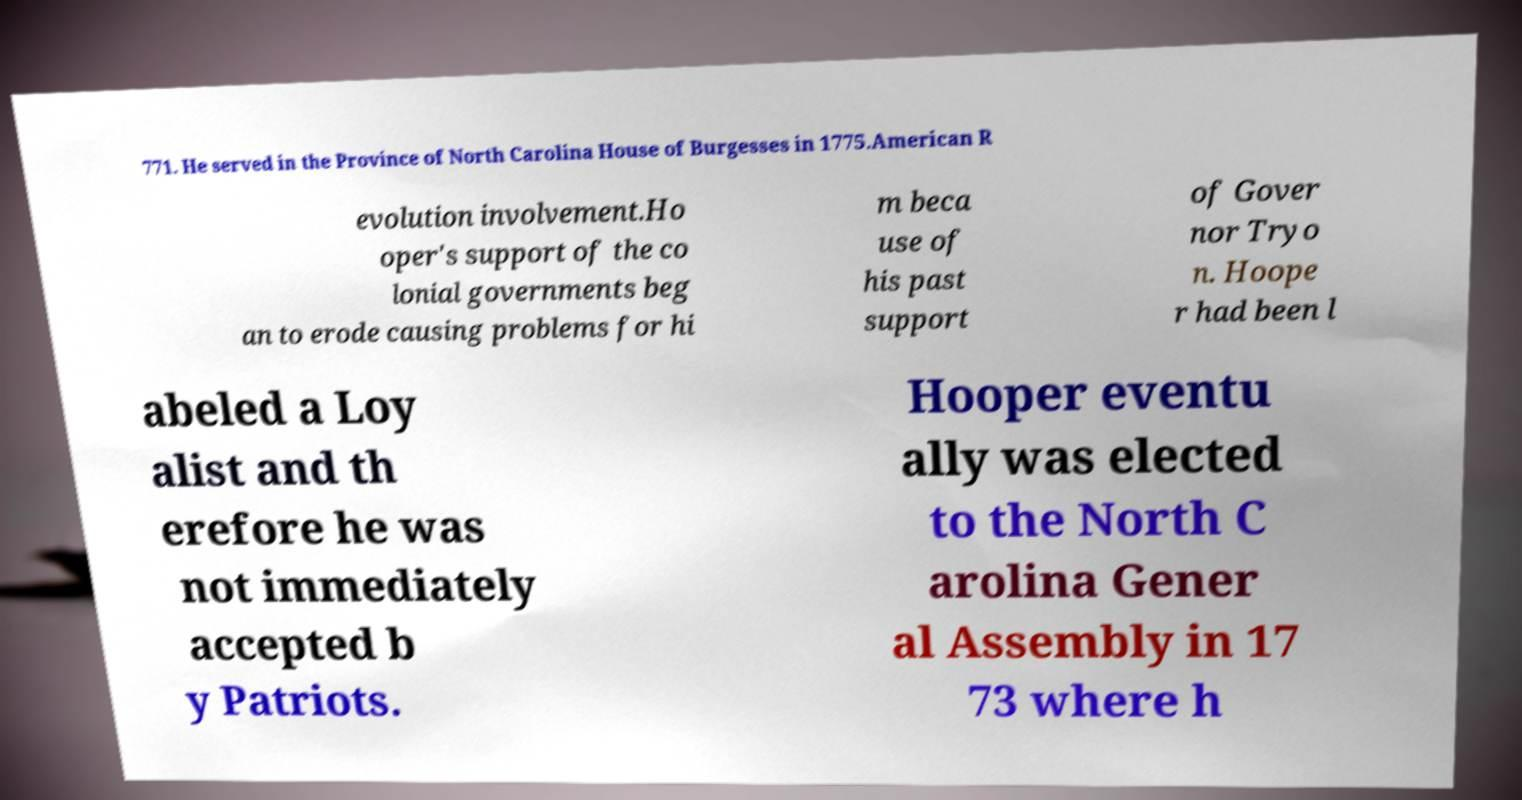There's text embedded in this image that I need extracted. Can you transcribe it verbatim? 771. He served in the Province of North Carolina House of Burgesses in 1775.American R evolution involvement.Ho oper's support of the co lonial governments beg an to erode causing problems for hi m beca use of his past support of Gover nor Tryo n. Hoope r had been l abeled a Loy alist and th erefore he was not immediately accepted b y Patriots. Hooper eventu ally was elected to the North C arolina Gener al Assembly in 17 73 where h 